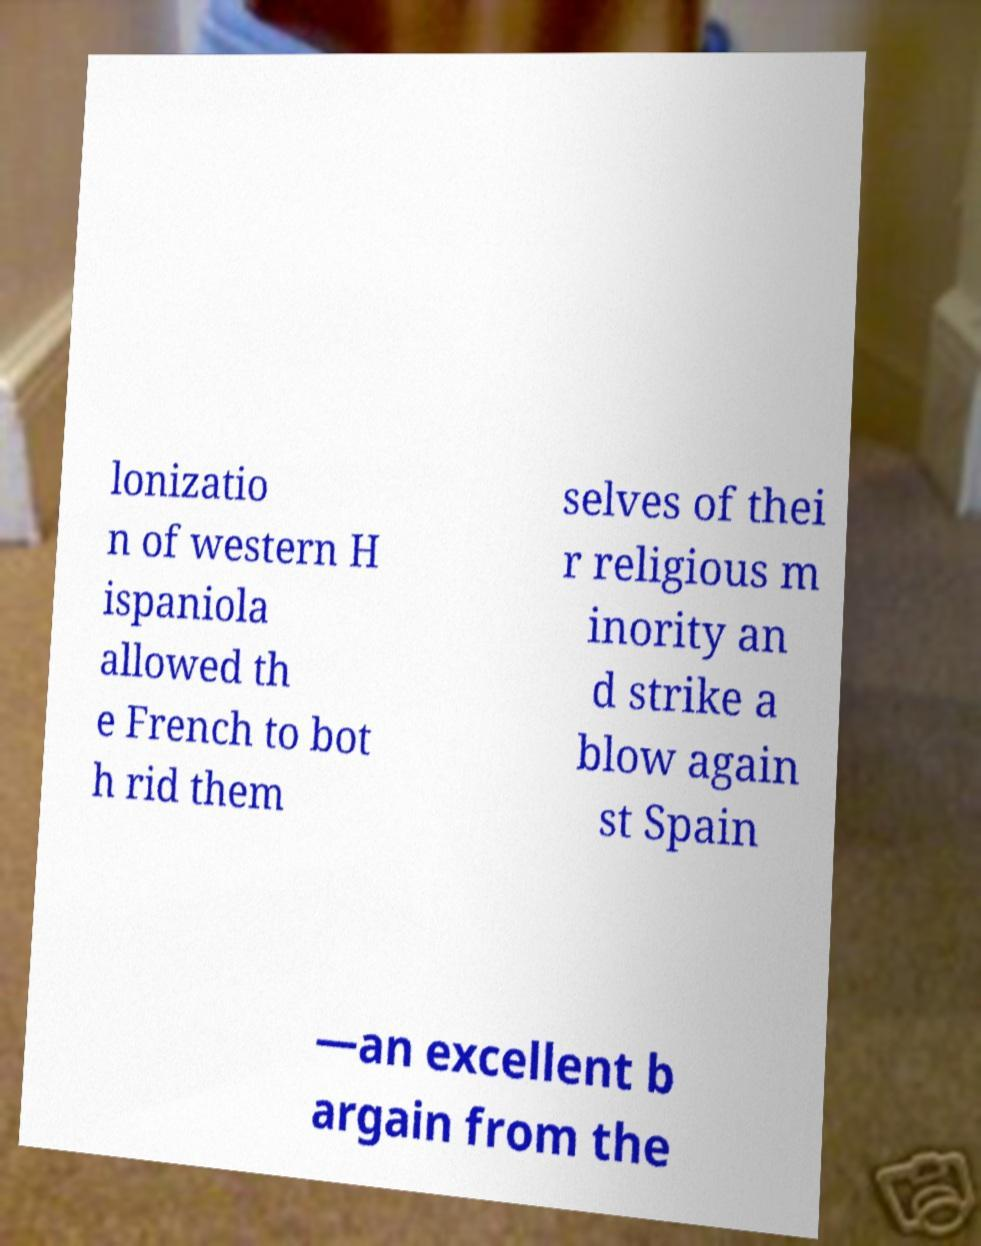I need the written content from this picture converted into text. Can you do that? lonizatio n of western H ispaniola allowed th e French to bot h rid them selves of thei r religious m inority an d strike a blow again st Spain —an excellent b argain from the 